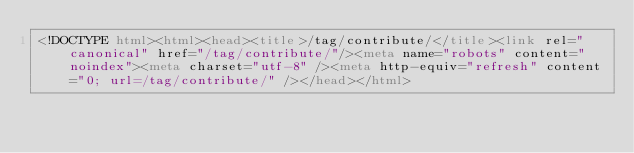<code> <loc_0><loc_0><loc_500><loc_500><_HTML_><!DOCTYPE html><html><head><title>/tag/contribute/</title><link rel="canonical" href="/tag/contribute/"/><meta name="robots" content="noindex"><meta charset="utf-8" /><meta http-equiv="refresh" content="0; url=/tag/contribute/" /></head></html></code> 